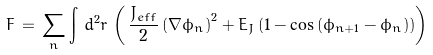Convert formula to latex. <formula><loc_0><loc_0><loc_500><loc_500>F \, = \, \sum _ { n } \int \, d ^ { 2 } r \, \left ( \, \frac { J _ { e f f } } { 2 } \left ( \nabla \phi _ { n } \right ) ^ { 2 } + E _ { J } \left ( 1 - \cos \left ( \phi _ { n + 1 } - \phi _ { n } \right ) \right ) \right )</formula> 